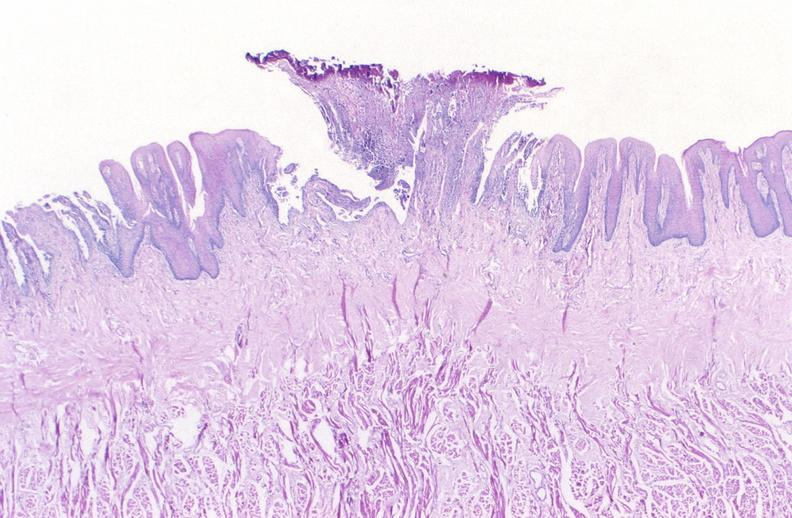does this image show tongue, herpes ulcer?
Answer the question using a single word or phrase. Yes 